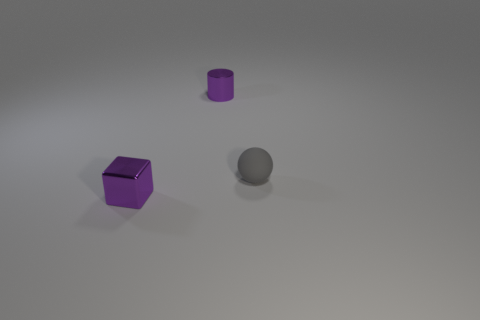There is a cube that is the same size as the gray sphere; what color is it?
Offer a terse response. Purple. How many things are either purple things that are behind the small metal cube or tiny gray matte spheres?
Provide a short and direct response. 2. How many other things are the same size as the cylinder?
Offer a terse response. 2. There is a purple thing that is left of the purple cylinder; what is its size?
Make the answer very short. Small. There is a tiny object that is made of the same material as the tiny purple block; what is its shape?
Your answer should be compact. Cylinder. Is there any other thing of the same color as the cube?
Make the answer very short. Yes. There is a shiny object behind the small thing that is in front of the gray matte object; what is its color?
Your response must be concise. Purple. How many big things are matte spheres or purple metal cylinders?
Give a very brief answer. 0. Are there any other things that are the same material as the small gray sphere?
Ensure brevity in your answer.  No. What is the color of the metallic cylinder?
Provide a short and direct response. Purple. 